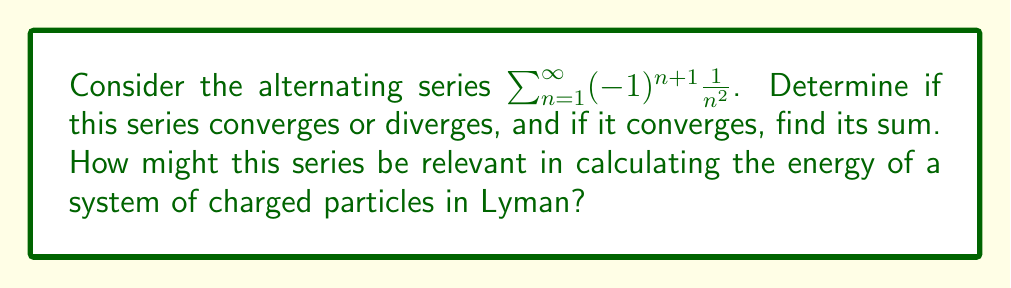Could you help me with this problem? Let's analyze this series step by step:

1) First, we need to check if this is indeed an alternating series. The general term is $a_n = (-1)^{n+1} \frac{1}{n^2}$, which alternates between positive and negative values as n increases. So, it is an alternating series.

2) To determine convergence, we can use the Alternating Series Test, which states that if:
   a) $\lim_{n \to \infty} |a_n| = 0$
   b) $|a_{n+1}| \leq |a_n|$ for all n ≥ some N

   Then the series converges.

3) Let's check condition (a):
   $\lim_{n \to \infty} |a_n| = \lim_{n \to \infty} |\frac{1}{n^2}| = 0$
   This condition is satisfied.

4) For condition (b):
   $|a_{n+1}| = \frac{1}{(n+1)^2} < \frac{1}{n^2} = |a_n|$ for all n ≥ 1
   This condition is also satisfied.

5) Since both conditions are met, the series converges.

6) To find the sum, we can use the fact that this is related to the Riemann zeta function:
   $\zeta(2) = \sum_{n=1}^{\infty} \frac{1}{n^2} = \frac{\pi^2}{6}$

7) Our series is the alternating version of this, so its sum S is:
   $S = \frac{1}{1^2} - \frac{1}{2^2} + \frac{1}{3^2} - \frac{1}{4^2} + ...$
   $S = \frac{\zeta(2)}{2} = \frac{\pi^2}{12}$

Relevance to charged particles in Lyman: This type of series often appears in quantum mechanics and electrostatics. In Lyman, when studying the energy levels of hydrogen atoms or the interaction energy of a system of charged particles, similar alternating series may arise in the calculations.
Answer: The series converges, and its sum is $\frac{\pi^2}{12}$. 